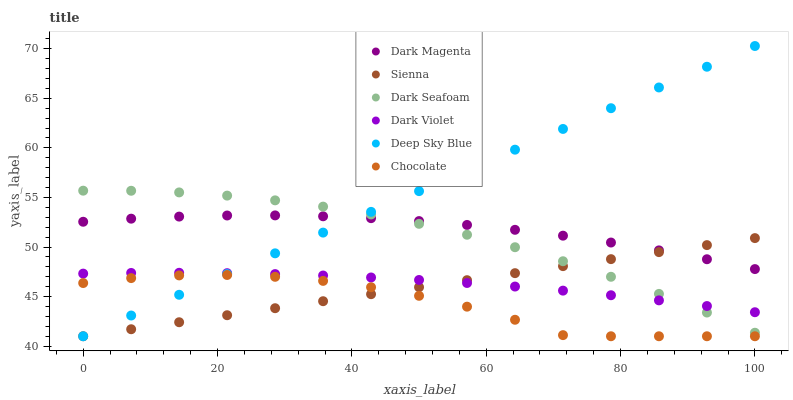Does Chocolate have the minimum area under the curve?
Answer yes or no. Yes. Does Deep Sky Blue have the maximum area under the curve?
Answer yes or no. Yes. Does Dark Violet have the minimum area under the curve?
Answer yes or no. No. Does Dark Violet have the maximum area under the curve?
Answer yes or no. No. Is Deep Sky Blue the smoothest?
Answer yes or no. Yes. Is Chocolate the roughest?
Answer yes or no. Yes. Is Dark Violet the smoothest?
Answer yes or no. No. Is Dark Violet the roughest?
Answer yes or no. No. Does Chocolate have the lowest value?
Answer yes or no. Yes. Does Dark Violet have the lowest value?
Answer yes or no. No. Does Deep Sky Blue have the highest value?
Answer yes or no. Yes. Does Dark Violet have the highest value?
Answer yes or no. No. Is Chocolate less than Dark Seafoam?
Answer yes or no. Yes. Is Dark Magenta greater than Dark Violet?
Answer yes or no. Yes. Does Deep Sky Blue intersect Dark Violet?
Answer yes or no. Yes. Is Deep Sky Blue less than Dark Violet?
Answer yes or no. No. Is Deep Sky Blue greater than Dark Violet?
Answer yes or no. No. Does Chocolate intersect Dark Seafoam?
Answer yes or no. No. 